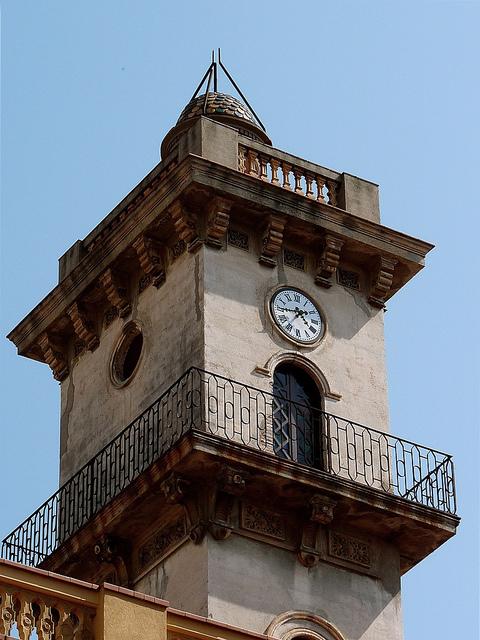What time does the clock read?
Write a very short answer. 4:45. Is there a balcony?
Short answer required. Yes. Is anyone on the balcony?
Quick response, please. No. 